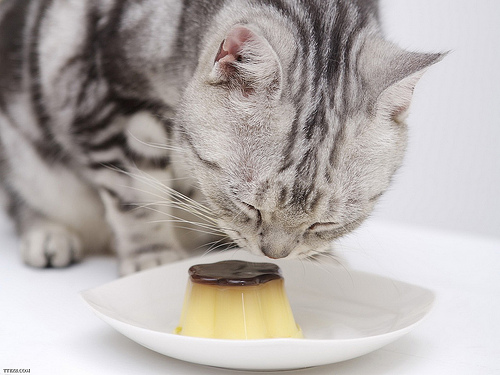Please provide the bounding box coordinate of the region this sentence describes: brown top on custard. The custard topped with a glistening brown glaze is centered on a plate, with the suggested region outlined by the coordinates [0.37, 0.64, 0.55, 0.74]. 